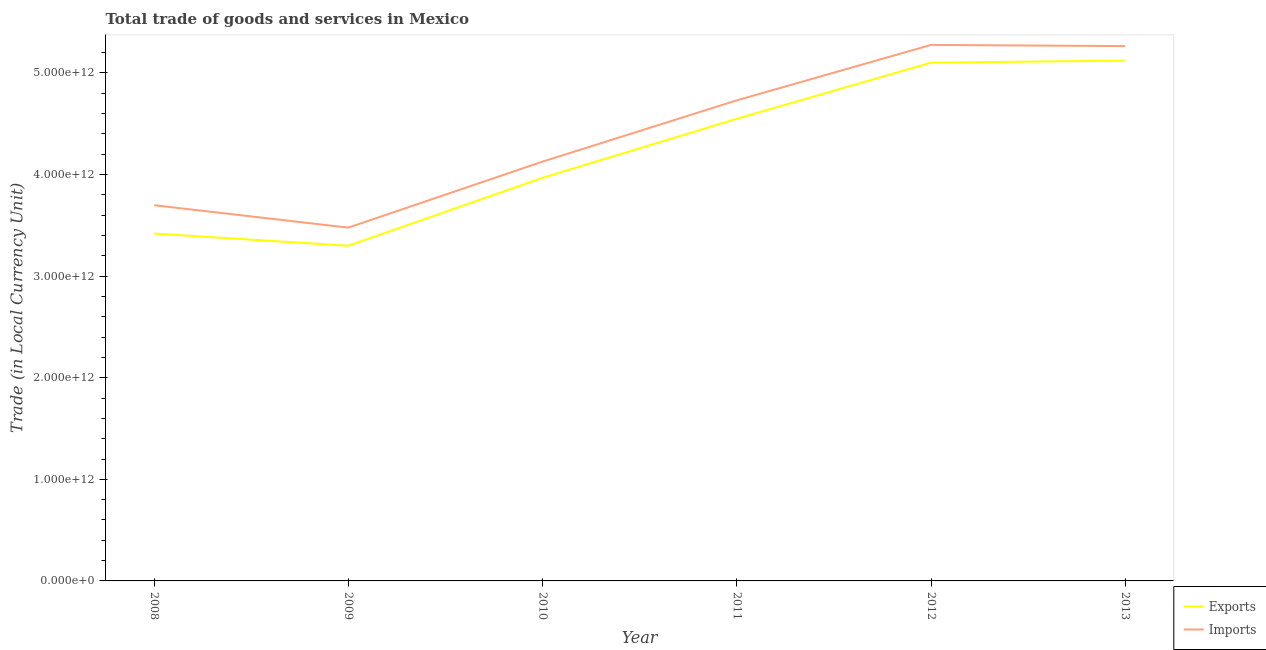Does the line corresponding to export of goods and services intersect with the line corresponding to imports of goods and services?
Make the answer very short. No. Is the number of lines equal to the number of legend labels?
Make the answer very short. Yes. What is the imports of goods and services in 2011?
Your response must be concise. 4.73e+12. Across all years, what is the maximum export of goods and services?
Your answer should be compact. 5.12e+12. Across all years, what is the minimum export of goods and services?
Provide a succinct answer. 3.30e+12. In which year was the export of goods and services maximum?
Offer a very short reply. 2013. What is the total imports of goods and services in the graph?
Your response must be concise. 2.66e+13. What is the difference between the export of goods and services in 2009 and that in 2013?
Your answer should be very brief. -1.82e+12. What is the difference between the export of goods and services in 2008 and the imports of goods and services in 2010?
Provide a succinct answer. -7.08e+11. What is the average export of goods and services per year?
Ensure brevity in your answer.  4.24e+12. In the year 2010, what is the difference between the export of goods and services and imports of goods and services?
Keep it short and to the point. -1.60e+11. In how many years, is the export of goods and services greater than 1200000000000 LCU?
Give a very brief answer. 6. What is the ratio of the imports of goods and services in 2009 to that in 2013?
Keep it short and to the point. 0.66. Is the export of goods and services in 2010 less than that in 2013?
Provide a short and direct response. Yes. What is the difference between the highest and the second highest imports of goods and services?
Make the answer very short. 1.16e+1. What is the difference between the highest and the lowest export of goods and services?
Your answer should be compact. 1.82e+12. In how many years, is the imports of goods and services greater than the average imports of goods and services taken over all years?
Your response must be concise. 3. Is the export of goods and services strictly less than the imports of goods and services over the years?
Your answer should be very brief. Yes. What is the difference between two consecutive major ticks on the Y-axis?
Give a very brief answer. 1.00e+12. Are the values on the major ticks of Y-axis written in scientific E-notation?
Make the answer very short. Yes. Where does the legend appear in the graph?
Provide a succinct answer. Bottom right. What is the title of the graph?
Your answer should be very brief. Total trade of goods and services in Mexico. What is the label or title of the X-axis?
Give a very brief answer. Year. What is the label or title of the Y-axis?
Your answer should be compact. Trade (in Local Currency Unit). What is the Trade (in Local Currency Unit) in Exports in 2008?
Make the answer very short. 3.42e+12. What is the Trade (in Local Currency Unit) of Imports in 2008?
Ensure brevity in your answer.  3.70e+12. What is the Trade (in Local Currency Unit) in Exports in 2009?
Offer a very short reply. 3.30e+12. What is the Trade (in Local Currency Unit) of Imports in 2009?
Give a very brief answer. 3.48e+12. What is the Trade (in Local Currency Unit) in Exports in 2010?
Make the answer very short. 3.97e+12. What is the Trade (in Local Currency Unit) of Imports in 2010?
Provide a short and direct response. 4.13e+12. What is the Trade (in Local Currency Unit) of Exports in 2011?
Provide a succinct answer. 4.55e+12. What is the Trade (in Local Currency Unit) in Imports in 2011?
Provide a short and direct response. 4.73e+12. What is the Trade (in Local Currency Unit) of Exports in 2012?
Provide a succinct answer. 5.10e+12. What is the Trade (in Local Currency Unit) in Imports in 2012?
Provide a short and direct response. 5.28e+12. What is the Trade (in Local Currency Unit) of Exports in 2013?
Your answer should be very brief. 5.12e+12. What is the Trade (in Local Currency Unit) of Imports in 2013?
Offer a terse response. 5.26e+12. Across all years, what is the maximum Trade (in Local Currency Unit) in Exports?
Keep it short and to the point. 5.12e+12. Across all years, what is the maximum Trade (in Local Currency Unit) in Imports?
Provide a short and direct response. 5.28e+12. Across all years, what is the minimum Trade (in Local Currency Unit) in Exports?
Your answer should be very brief. 3.30e+12. Across all years, what is the minimum Trade (in Local Currency Unit) of Imports?
Provide a short and direct response. 3.48e+12. What is the total Trade (in Local Currency Unit) in Exports in the graph?
Provide a short and direct response. 2.55e+13. What is the total Trade (in Local Currency Unit) of Imports in the graph?
Your answer should be compact. 2.66e+13. What is the difference between the Trade (in Local Currency Unit) in Exports in 2008 and that in 2009?
Ensure brevity in your answer.  1.20e+11. What is the difference between the Trade (in Local Currency Unit) of Imports in 2008 and that in 2009?
Offer a very short reply. 2.21e+11. What is the difference between the Trade (in Local Currency Unit) of Exports in 2008 and that in 2010?
Your answer should be compact. -5.48e+11. What is the difference between the Trade (in Local Currency Unit) in Imports in 2008 and that in 2010?
Offer a very short reply. -4.29e+11. What is the difference between the Trade (in Local Currency Unit) of Exports in 2008 and that in 2011?
Ensure brevity in your answer.  -1.13e+12. What is the difference between the Trade (in Local Currency Unit) of Imports in 2008 and that in 2011?
Your answer should be very brief. -1.03e+12. What is the difference between the Trade (in Local Currency Unit) of Exports in 2008 and that in 2012?
Provide a succinct answer. -1.68e+12. What is the difference between the Trade (in Local Currency Unit) in Imports in 2008 and that in 2012?
Make the answer very short. -1.58e+12. What is the difference between the Trade (in Local Currency Unit) in Exports in 2008 and that in 2013?
Your answer should be very brief. -1.70e+12. What is the difference between the Trade (in Local Currency Unit) of Imports in 2008 and that in 2013?
Your answer should be very brief. -1.57e+12. What is the difference between the Trade (in Local Currency Unit) of Exports in 2009 and that in 2010?
Ensure brevity in your answer.  -6.68e+11. What is the difference between the Trade (in Local Currency Unit) in Imports in 2009 and that in 2010?
Ensure brevity in your answer.  -6.50e+11. What is the difference between the Trade (in Local Currency Unit) of Exports in 2009 and that in 2011?
Make the answer very short. -1.25e+12. What is the difference between the Trade (in Local Currency Unit) in Imports in 2009 and that in 2011?
Your answer should be compact. -1.25e+12. What is the difference between the Trade (in Local Currency Unit) in Exports in 2009 and that in 2012?
Provide a succinct answer. -1.80e+12. What is the difference between the Trade (in Local Currency Unit) in Imports in 2009 and that in 2012?
Your answer should be very brief. -1.80e+12. What is the difference between the Trade (in Local Currency Unit) in Exports in 2009 and that in 2013?
Offer a terse response. -1.82e+12. What is the difference between the Trade (in Local Currency Unit) of Imports in 2009 and that in 2013?
Offer a terse response. -1.79e+12. What is the difference between the Trade (in Local Currency Unit) in Exports in 2010 and that in 2011?
Ensure brevity in your answer.  -5.81e+11. What is the difference between the Trade (in Local Currency Unit) in Imports in 2010 and that in 2011?
Make the answer very short. -6.03e+11. What is the difference between the Trade (in Local Currency Unit) of Exports in 2010 and that in 2012?
Provide a succinct answer. -1.13e+12. What is the difference between the Trade (in Local Currency Unit) in Imports in 2010 and that in 2012?
Ensure brevity in your answer.  -1.15e+12. What is the difference between the Trade (in Local Currency Unit) in Exports in 2010 and that in 2013?
Offer a very short reply. -1.15e+12. What is the difference between the Trade (in Local Currency Unit) in Imports in 2010 and that in 2013?
Your answer should be compact. -1.14e+12. What is the difference between the Trade (in Local Currency Unit) in Exports in 2011 and that in 2012?
Provide a short and direct response. -5.52e+11. What is the difference between the Trade (in Local Currency Unit) of Imports in 2011 and that in 2012?
Give a very brief answer. -5.46e+11. What is the difference between the Trade (in Local Currency Unit) of Exports in 2011 and that in 2013?
Offer a very short reply. -5.73e+11. What is the difference between the Trade (in Local Currency Unit) of Imports in 2011 and that in 2013?
Offer a very short reply. -5.34e+11. What is the difference between the Trade (in Local Currency Unit) in Exports in 2012 and that in 2013?
Provide a short and direct response. -2.02e+1. What is the difference between the Trade (in Local Currency Unit) in Imports in 2012 and that in 2013?
Your answer should be compact. 1.16e+1. What is the difference between the Trade (in Local Currency Unit) of Exports in 2008 and the Trade (in Local Currency Unit) of Imports in 2009?
Your response must be concise. -5.81e+1. What is the difference between the Trade (in Local Currency Unit) of Exports in 2008 and the Trade (in Local Currency Unit) of Imports in 2010?
Offer a terse response. -7.08e+11. What is the difference between the Trade (in Local Currency Unit) of Exports in 2008 and the Trade (in Local Currency Unit) of Imports in 2011?
Offer a terse response. -1.31e+12. What is the difference between the Trade (in Local Currency Unit) in Exports in 2008 and the Trade (in Local Currency Unit) in Imports in 2012?
Ensure brevity in your answer.  -1.86e+12. What is the difference between the Trade (in Local Currency Unit) of Exports in 2008 and the Trade (in Local Currency Unit) of Imports in 2013?
Offer a very short reply. -1.85e+12. What is the difference between the Trade (in Local Currency Unit) in Exports in 2009 and the Trade (in Local Currency Unit) in Imports in 2010?
Keep it short and to the point. -8.28e+11. What is the difference between the Trade (in Local Currency Unit) of Exports in 2009 and the Trade (in Local Currency Unit) of Imports in 2011?
Your response must be concise. -1.43e+12. What is the difference between the Trade (in Local Currency Unit) of Exports in 2009 and the Trade (in Local Currency Unit) of Imports in 2012?
Your answer should be very brief. -1.98e+12. What is the difference between the Trade (in Local Currency Unit) of Exports in 2009 and the Trade (in Local Currency Unit) of Imports in 2013?
Your answer should be very brief. -1.97e+12. What is the difference between the Trade (in Local Currency Unit) of Exports in 2010 and the Trade (in Local Currency Unit) of Imports in 2011?
Keep it short and to the point. -7.63e+11. What is the difference between the Trade (in Local Currency Unit) of Exports in 2010 and the Trade (in Local Currency Unit) of Imports in 2012?
Provide a succinct answer. -1.31e+12. What is the difference between the Trade (in Local Currency Unit) of Exports in 2010 and the Trade (in Local Currency Unit) of Imports in 2013?
Your answer should be very brief. -1.30e+12. What is the difference between the Trade (in Local Currency Unit) in Exports in 2011 and the Trade (in Local Currency Unit) in Imports in 2012?
Offer a very short reply. -7.27e+11. What is the difference between the Trade (in Local Currency Unit) in Exports in 2011 and the Trade (in Local Currency Unit) in Imports in 2013?
Your response must be concise. -7.16e+11. What is the difference between the Trade (in Local Currency Unit) of Exports in 2012 and the Trade (in Local Currency Unit) of Imports in 2013?
Give a very brief answer. -1.63e+11. What is the average Trade (in Local Currency Unit) in Exports per year?
Give a very brief answer. 4.24e+12. What is the average Trade (in Local Currency Unit) of Imports per year?
Give a very brief answer. 4.43e+12. In the year 2008, what is the difference between the Trade (in Local Currency Unit) in Exports and Trade (in Local Currency Unit) in Imports?
Keep it short and to the point. -2.79e+11. In the year 2009, what is the difference between the Trade (in Local Currency Unit) in Exports and Trade (in Local Currency Unit) in Imports?
Offer a very short reply. -1.78e+11. In the year 2010, what is the difference between the Trade (in Local Currency Unit) in Exports and Trade (in Local Currency Unit) in Imports?
Your answer should be compact. -1.60e+11. In the year 2011, what is the difference between the Trade (in Local Currency Unit) in Exports and Trade (in Local Currency Unit) in Imports?
Ensure brevity in your answer.  -1.82e+11. In the year 2012, what is the difference between the Trade (in Local Currency Unit) of Exports and Trade (in Local Currency Unit) of Imports?
Your answer should be very brief. -1.75e+11. In the year 2013, what is the difference between the Trade (in Local Currency Unit) of Exports and Trade (in Local Currency Unit) of Imports?
Offer a very short reply. -1.43e+11. What is the ratio of the Trade (in Local Currency Unit) in Exports in 2008 to that in 2009?
Your answer should be compact. 1.04. What is the ratio of the Trade (in Local Currency Unit) in Imports in 2008 to that in 2009?
Ensure brevity in your answer.  1.06. What is the ratio of the Trade (in Local Currency Unit) of Exports in 2008 to that in 2010?
Provide a short and direct response. 0.86. What is the ratio of the Trade (in Local Currency Unit) of Imports in 2008 to that in 2010?
Your answer should be compact. 0.9. What is the ratio of the Trade (in Local Currency Unit) in Exports in 2008 to that in 2011?
Make the answer very short. 0.75. What is the ratio of the Trade (in Local Currency Unit) of Imports in 2008 to that in 2011?
Offer a terse response. 0.78. What is the ratio of the Trade (in Local Currency Unit) of Exports in 2008 to that in 2012?
Provide a succinct answer. 0.67. What is the ratio of the Trade (in Local Currency Unit) in Imports in 2008 to that in 2012?
Provide a succinct answer. 0.7. What is the ratio of the Trade (in Local Currency Unit) in Exports in 2008 to that in 2013?
Your answer should be compact. 0.67. What is the ratio of the Trade (in Local Currency Unit) in Imports in 2008 to that in 2013?
Offer a terse response. 0.7. What is the ratio of the Trade (in Local Currency Unit) of Exports in 2009 to that in 2010?
Your response must be concise. 0.83. What is the ratio of the Trade (in Local Currency Unit) of Imports in 2009 to that in 2010?
Offer a terse response. 0.84. What is the ratio of the Trade (in Local Currency Unit) in Exports in 2009 to that in 2011?
Your answer should be very brief. 0.73. What is the ratio of the Trade (in Local Currency Unit) of Imports in 2009 to that in 2011?
Provide a succinct answer. 0.74. What is the ratio of the Trade (in Local Currency Unit) in Exports in 2009 to that in 2012?
Your answer should be compact. 0.65. What is the ratio of the Trade (in Local Currency Unit) in Imports in 2009 to that in 2012?
Offer a very short reply. 0.66. What is the ratio of the Trade (in Local Currency Unit) of Exports in 2009 to that in 2013?
Provide a short and direct response. 0.64. What is the ratio of the Trade (in Local Currency Unit) in Imports in 2009 to that in 2013?
Keep it short and to the point. 0.66. What is the ratio of the Trade (in Local Currency Unit) of Exports in 2010 to that in 2011?
Ensure brevity in your answer.  0.87. What is the ratio of the Trade (in Local Currency Unit) in Imports in 2010 to that in 2011?
Give a very brief answer. 0.87. What is the ratio of the Trade (in Local Currency Unit) in Exports in 2010 to that in 2012?
Your answer should be very brief. 0.78. What is the ratio of the Trade (in Local Currency Unit) of Imports in 2010 to that in 2012?
Offer a terse response. 0.78. What is the ratio of the Trade (in Local Currency Unit) of Exports in 2010 to that in 2013?
Keep it short and to the point. 0.77. What is the ratio of the Trade (in Local Currency Unit) in Imports in 2010 to that in 2013?
Offer a very short reply. 0.78. What is the ratio of the Trade (in Local Currency Unit) of Exports in 2011 to that in 2012?
Provide a succinct answer. 0.89. What is the ratio of the Trade (in Local Currency Unit) in Imports in 2011 to that in 2012?
Provide a succinct answer. 0.9. What is the ratio of the Trade (in Local Currency Unit) of Exports in 2011 to that in 2013?
Keep it short and to the point. 0.89. What is the ratio of the Trade (in Local Currency Unit) of Imports in 2011 to that in 2013?
Provide a succinct answer. 0.9. What is the ratio of the Trade (in Local Currency Unit) of Exports in 2012 to that in 2013?
Offer a terse response. 1. What is the difference between the highest and the second highest Trade (in Local Currency Unit) in Exports?
Your answer should be very brief. 2.02e+1. What is the difference between the highest and the second highest Trade (in Local Currency Unit) of Imports?
Ensure brevity in your answer.  1.16e+1. What is the difference between the highest and the lowest Trade (in Local Currency Unit) in Exports?
Ensure brevity in your answer.  1.82e+12. What is the difference between the highest and the lowest Trade (in Local Currency Unit) of Imports?
Keep it short and to the point. 1.80e+12. 